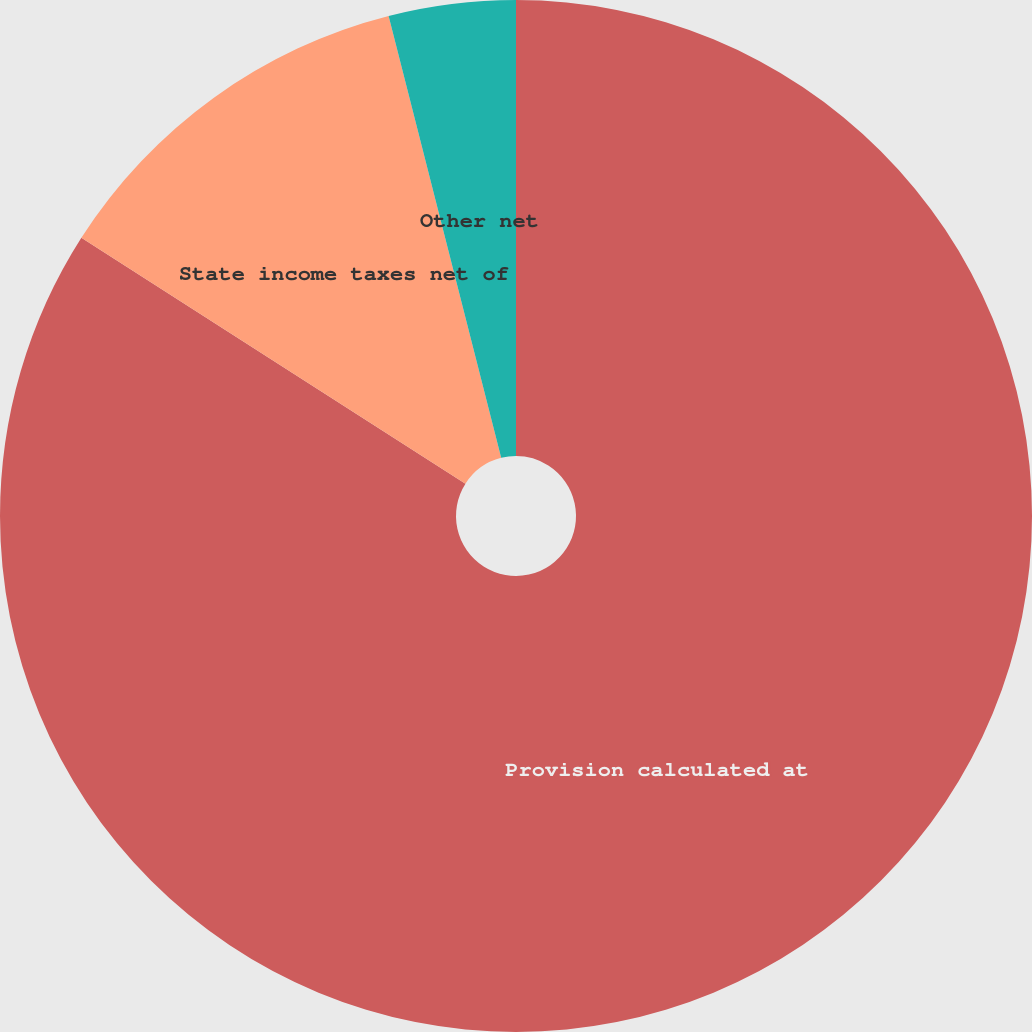<chart> <loc_0><loc_0><loc_500><loc_500><pie_chart><fcel>Provision calculated at<fcel>State income taxes net of<fcel>Other net<nl><fcel>84.06%<fcel>11.97%<fcel>3.97%<nl></chart> 